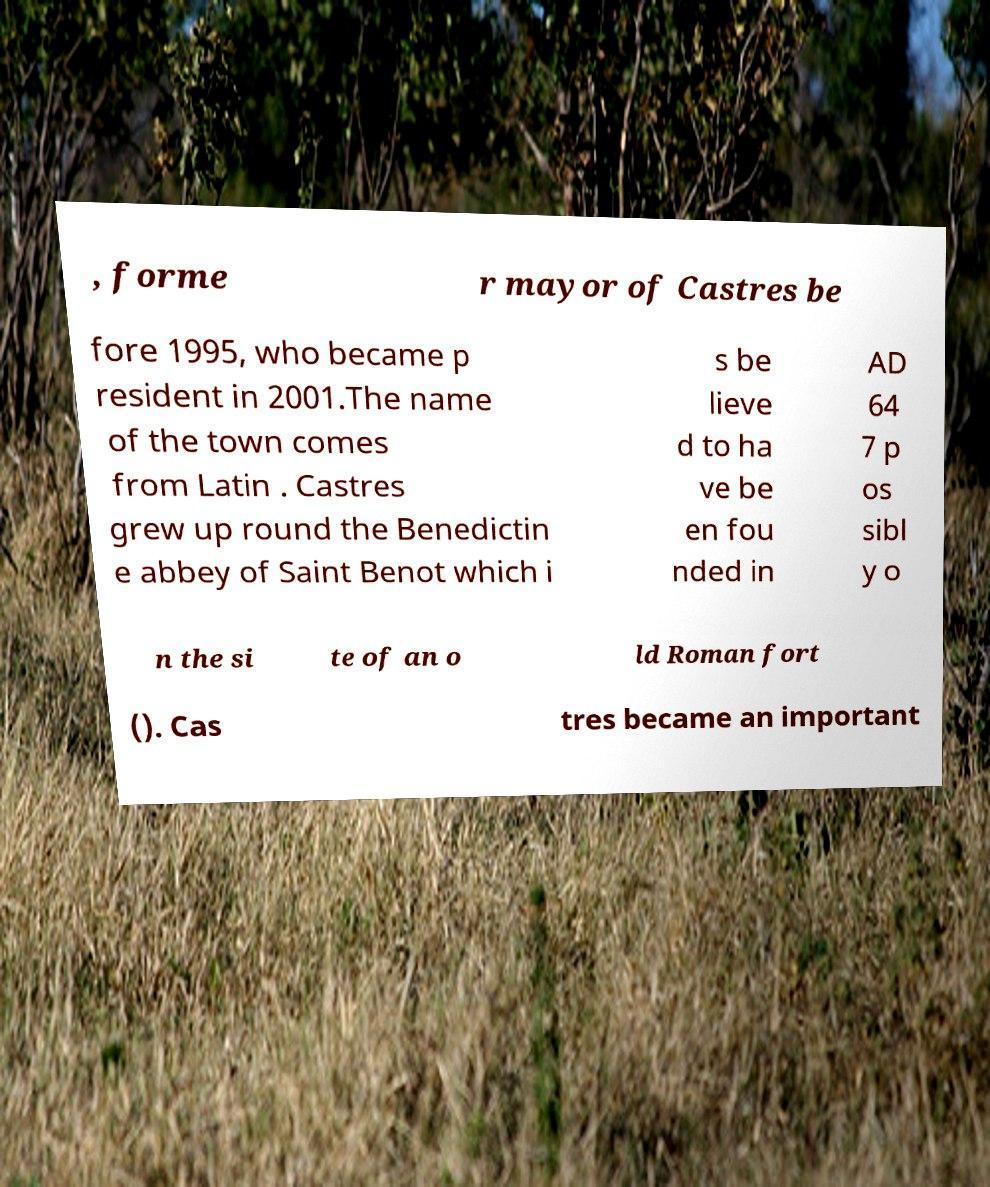Could you extract and type out the text from this image? , forme r mayor of Castres be fore 1995, who became p resident in 2001.The name of the town comes from Latin . Castres grew up round the Benedictin e abbey of Saint Benot which i s be lieve d to ha ve be en fou nded in AD 64 7 p os sibl y o n the si te of an o ld Roman fort (). Cas tres became an important 